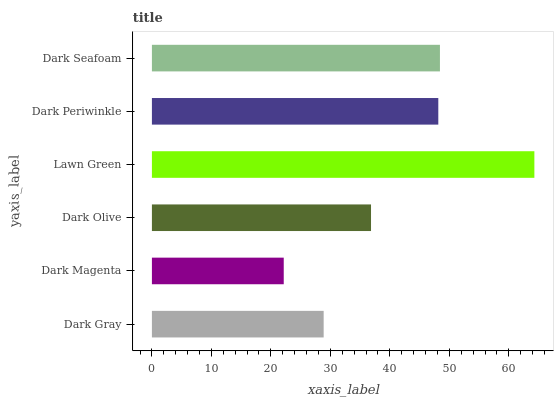Is Dark Magenta the minimum?
Answer yes or no. Yes. Is Lawn Green the maximum?
Answer yes or no. Yes. Is Dark Olive the minimum?
Answer yes or no. No. Is Dark Olive the maximum?
Answer yes or no. No. Is Dark Olive greater than Dark Magenta?
Answer yes or no. Yes. Is Dark Magenta less than Dark Olive?
Answer yes or no. Yes. Is Dark Magenta greater than Dark Olive?
Answer yes or no. No. Is Dark Olive less than Dark Magenta?
Answer yes or no. No. Is Dark Periwinkle the high median?
Answer yes or no. Yes. Is Dark Olive the low median?
Answer yes or no. Yes. Is Dark Olive the high median?
Answer yes or no. No. Is Dark Seafoam the low median?
Answer yes or no. No. 